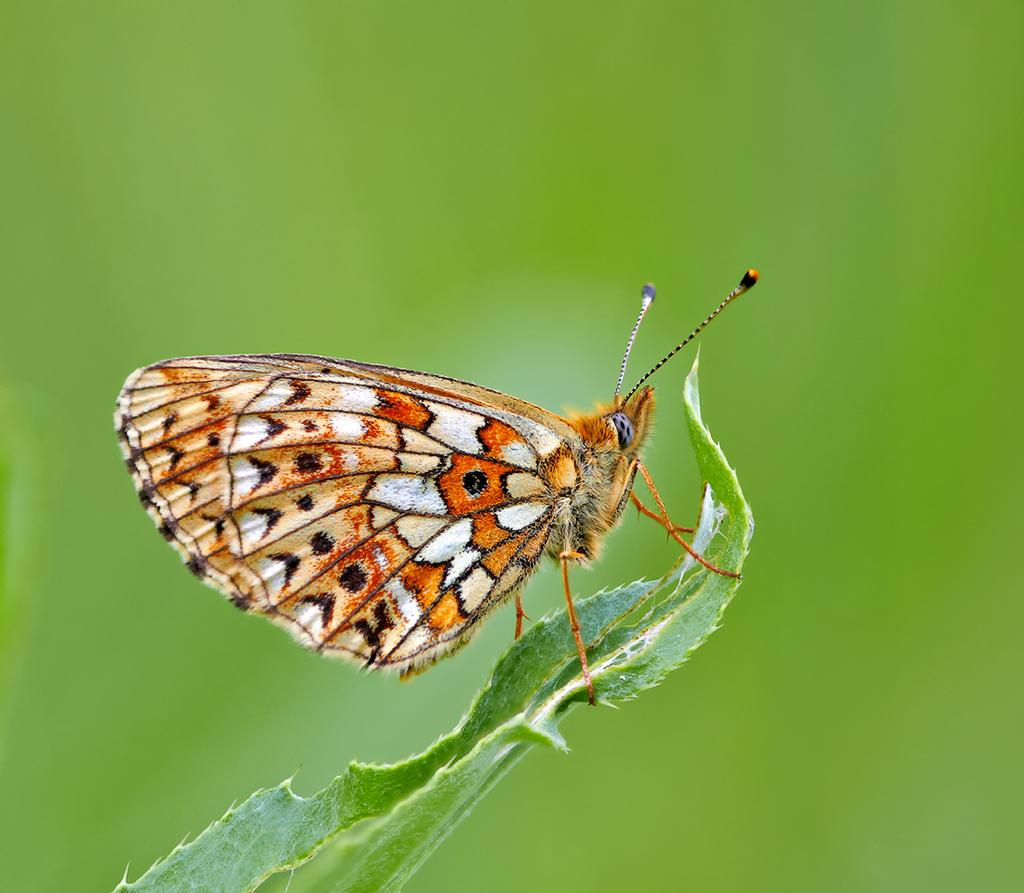What is the main subject of the image? There is a leaf in the image. Is there anything on the leaf? Yes, there is a butterfly on the leaf. Can you describe the background of the image? The background of the image is blurred. What type of quartz can be seen hanging from the leaf in the image? There is no quartz present in the image; it features a leaf with a butterfly on it. How many potatoes are visible on the leaf in the image? There are no potatoes visible on the leaf in the image. 